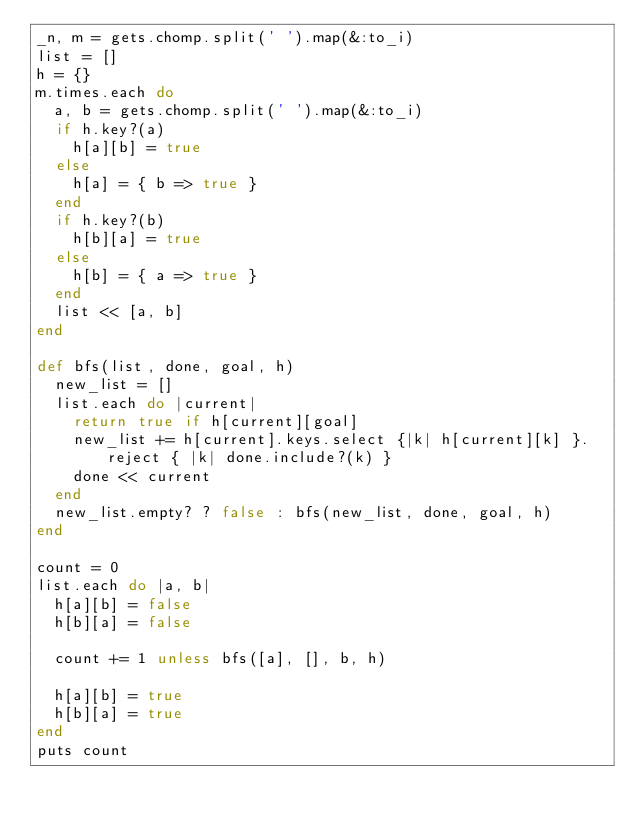<code> <loc_0><loc_0><loc_500><loc_500><_Ruby_>_n, m = gets.chomp.split(' ').map(&:to_i)
list = []
h = {}
m.times.each do
  a, b = gets.chomp.split(' ').map(&:to_i)
  if h.key?(a)
    h[a][b] = true
  else
    h[a] = { b => true }
  end
  if h.key?(b)
    h[b][a] = true
  else
    h[b] = { a => true }
  end
  list << [a, b]
end

def bfs(list, done, goal, h)
  new_list = []
  list.each do |current|
    return true if h[current][goal]
    new_list += h[current].keys.select {|k| h[current][k] }.reject { |k| done.include?(k) }
    done << current
  end
  new_list.empty? ? false : bfs(new_list, done, goal, h)
end

count = 0
list.each do |a, b|
  h[a][b] = false
  h[b][a] = false

  count += 1 unless bfs([a], [], b, h)

  h[a][b] = true
  h[b][a] = true
end
puts count
</code> 